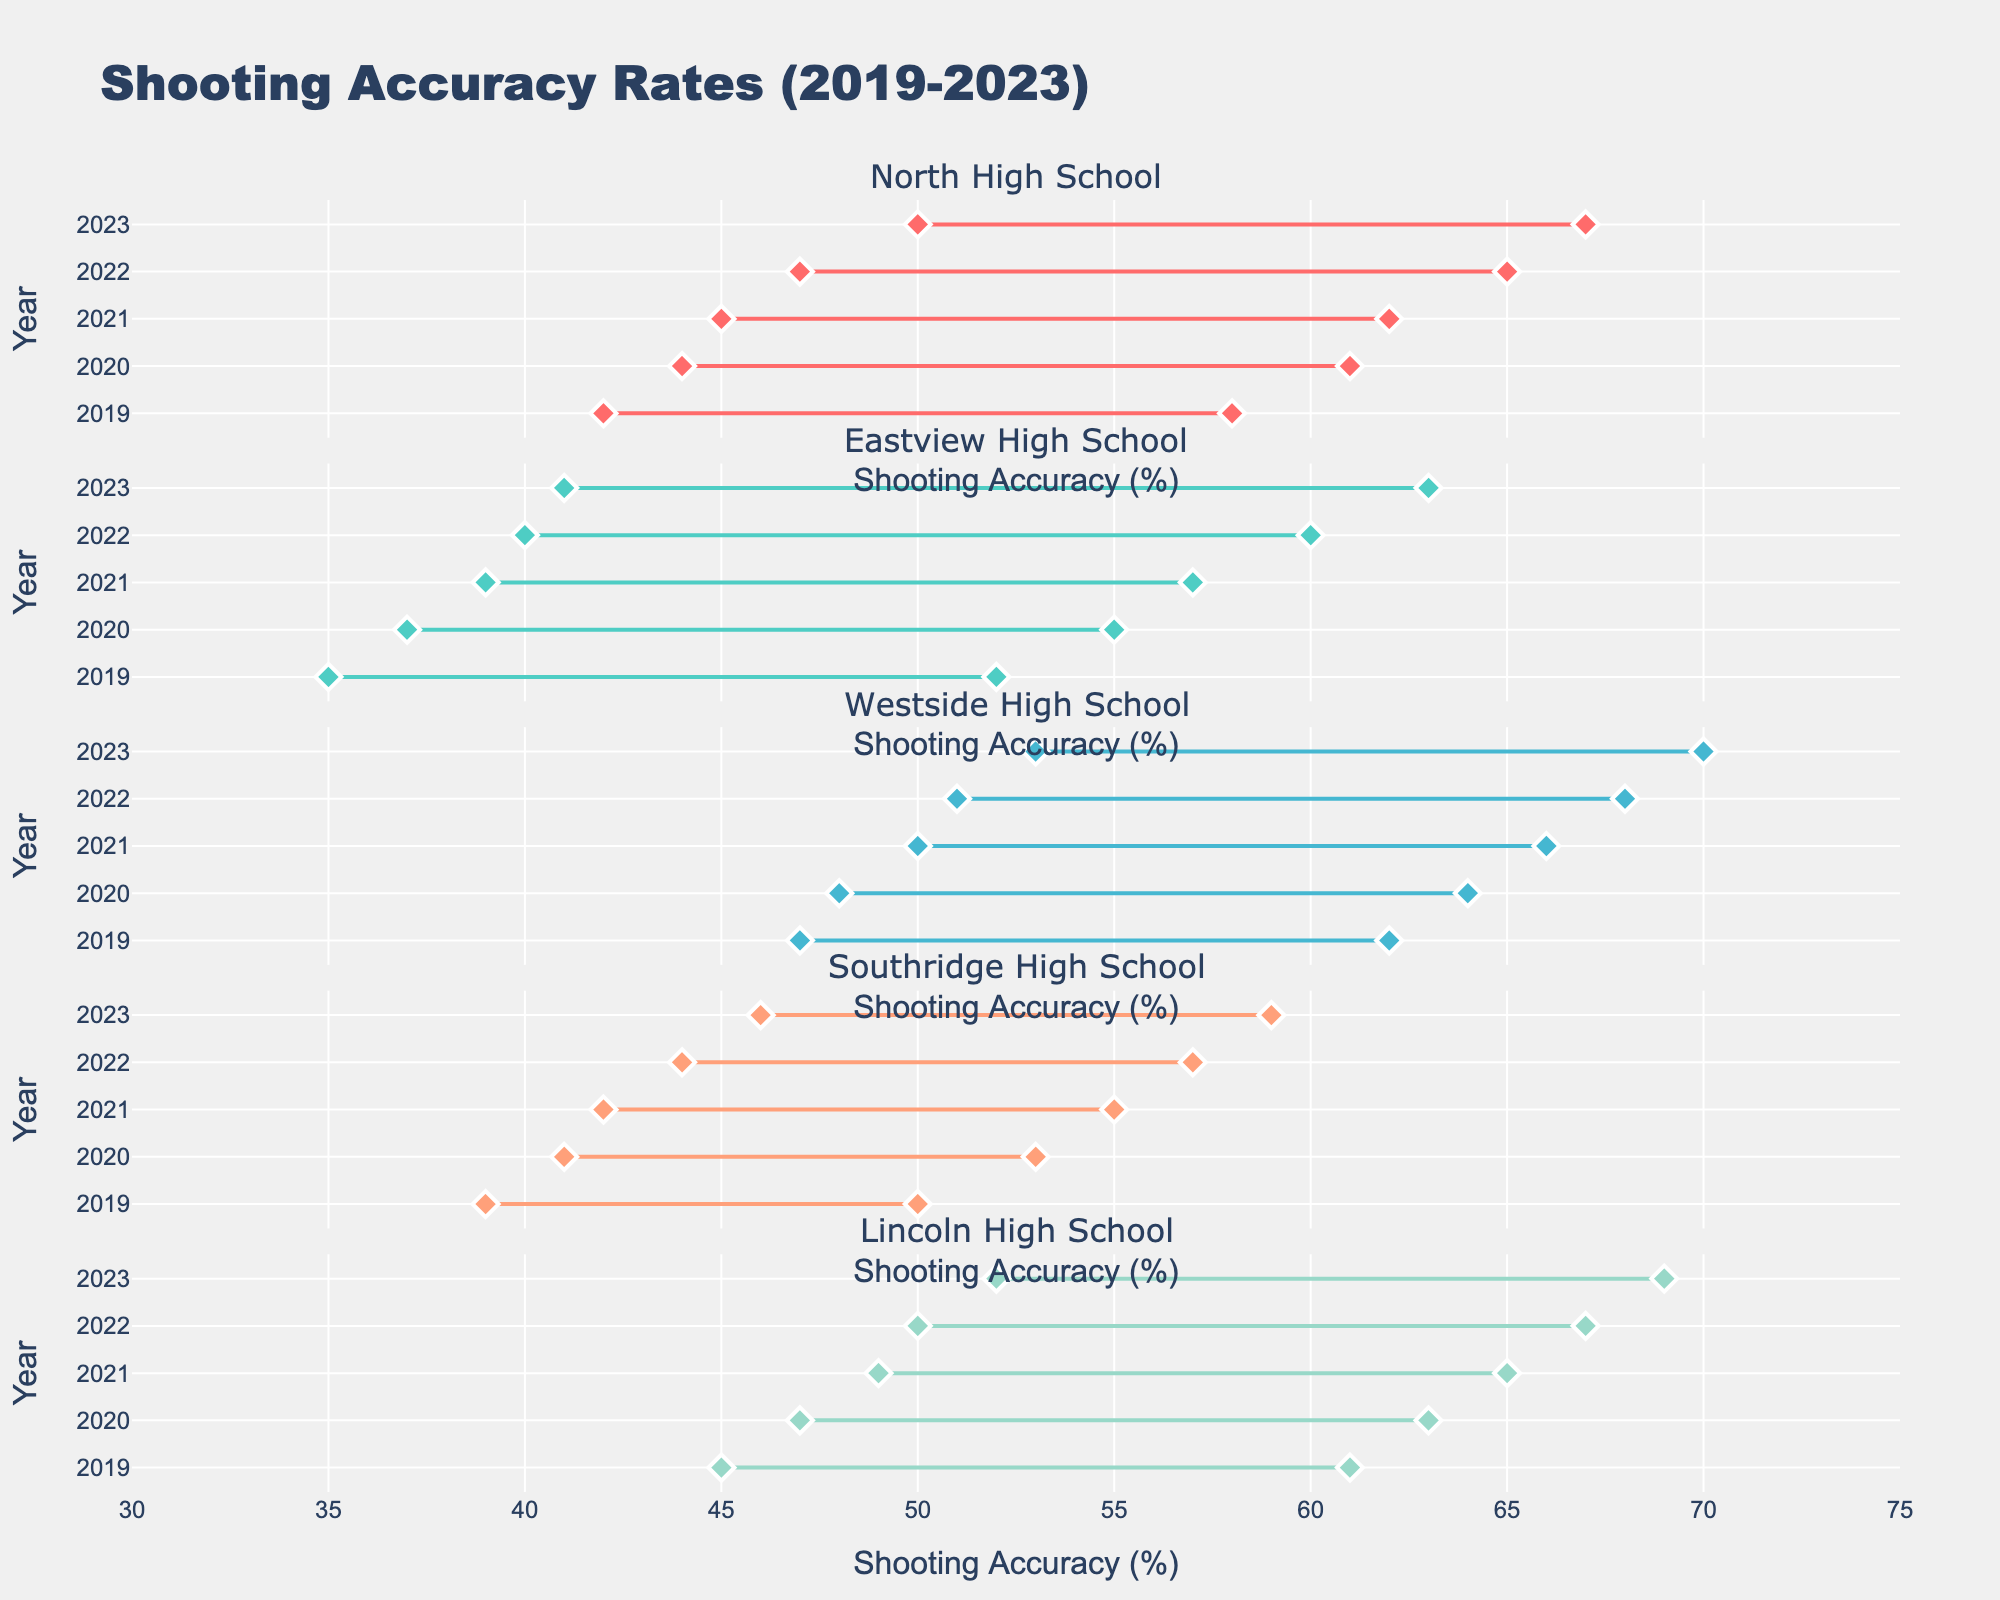What's the title of the figure? The title of the figure can be found at the top of the plot. It reads "Shooting Accuracy Rates (2019-2023)."
Answer: Shooting Accuracy Rates (2019-2023) What is the minimum shooting accuracy rate for Westside High School in 2022? Look at the subplot for Westside High School and find the range for the year 2022. The minimum value can be seen at the lower end of the line for that year.
Answer: 51% How has the shooting accuracy range of Eastview High School changed from 2019 to 2023? Observe the lines for Eastview High School for the years 2019 and 2023. Compare the minimum and maximum shooting accuracy for these years. In 2019, the range is 35%-52%, and in 2023 it is 41%-63%.
Answer: Increased Which team had the highest maximum shooting accuracy rate in 2023? Check the maximum points for all the teams in the year 2023. The highest can be found by comparing these points. Westside High School has the highest maximum shooting accuracy of 70% in 2023.
Answer: Westside High School What is the shooting accuracy range for Lincoln High School in 2020? Find the subplot for Lincoln High School and locate the year 2020. The accuracy range is between the minimum and maximum points for that year.
Answer: 47%-63% Did North High School improve their minimum shooting accuracy from 2019 to 2023? Compare North High School's minimum shooting accuracy in 2019 and 2023. In 2019, it was 42%, and in 2023, it increased to 50%.
Answer: Yes Which team had the smallest range of shooting accuracy in 2019? Check the ranges for all teams in 2019. The smallest range is calculated by subtracting the minimum from the maximum value for each team. Southridge High School has a range of 39%-50%, which is the smallest range.
Answer: Southridge High School On average, did the maximum shooting accuracy rates for all teams increase from 2019 to 2023? Calculate the average maximum shooting accuracy for all teams in 2019 and 2023. In 2019: (58 + 52 + 62 + 50 + 61) / 5 = 56.6%. In 2023: (67 + 63 + 70 + 59 + 69) / 5 = 65.6%. The average did increase.
Answer: Yes By what percent did Southridge High School's maximum shooting accuracy improve from 2019 to 2023? Look at Southridge High School's maximum shooting accuracy in 2019 and 2023. In 2019, it was 50%. In 2023, it was 59%. The percent improvement is ((59-50)/50)*100 = 18%.
Answer: 18% Which team had the largest increase in their minimum shooting accuracy from 2019 to 2023? Compare the minimum shooting accuracy for each team in 2019 and 2023, then calculate the increase. The largest increase is found by identifying the highest difference. Lincoln High School's minimum increased from 45% in 2019 to 52% in 2023, a 7% increase which is the largest.
Answer: Lincoln High School 